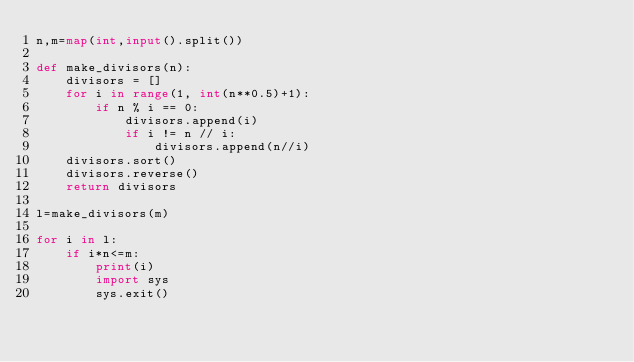<code> <loc_0><loc_0><loc_500><loc_500><_Python_>n,m=map(int,input().split())

def make_divisors(n):
    divisors = []
    for i in range(1, int(n**0.5)+1):
        if n % i == 0:
            divisors.append(i)
            if i != n // i:
                divisors.append(n//i)
    divisors.sort()
    divisors.reverse()
    return divisors

l=make_divisors(m)

for i in l:
    if i*n<=m:
        print(i)
        import sys
        sys.exit()
</code> 